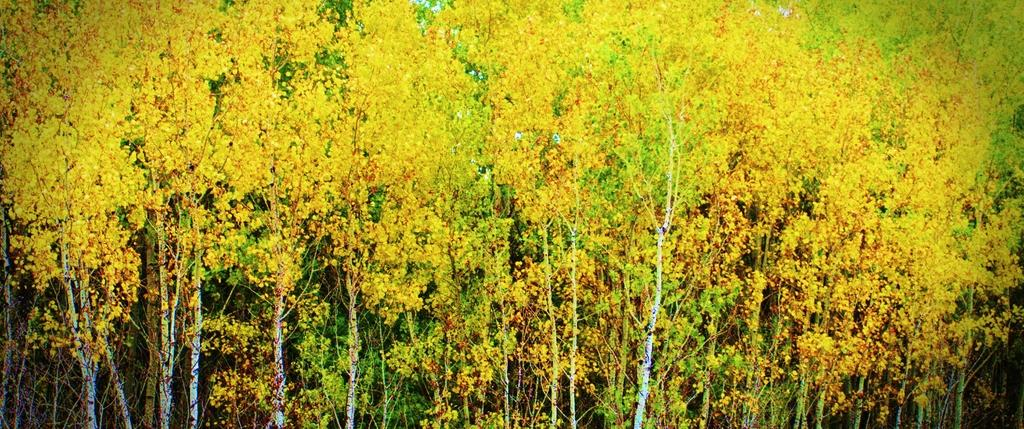What type of vegetation is present in the image? There are trees in the image. What color are the leaves on the trees? The trees have both yellow and green leaves. Can you describe the appearance of the trees in the image? The trees have a mix of yellow and green leaves. Is there a farmer in the image wearing a hat? There is no farmer or hat present in the image; it only features trees with yellow and green leaves. 